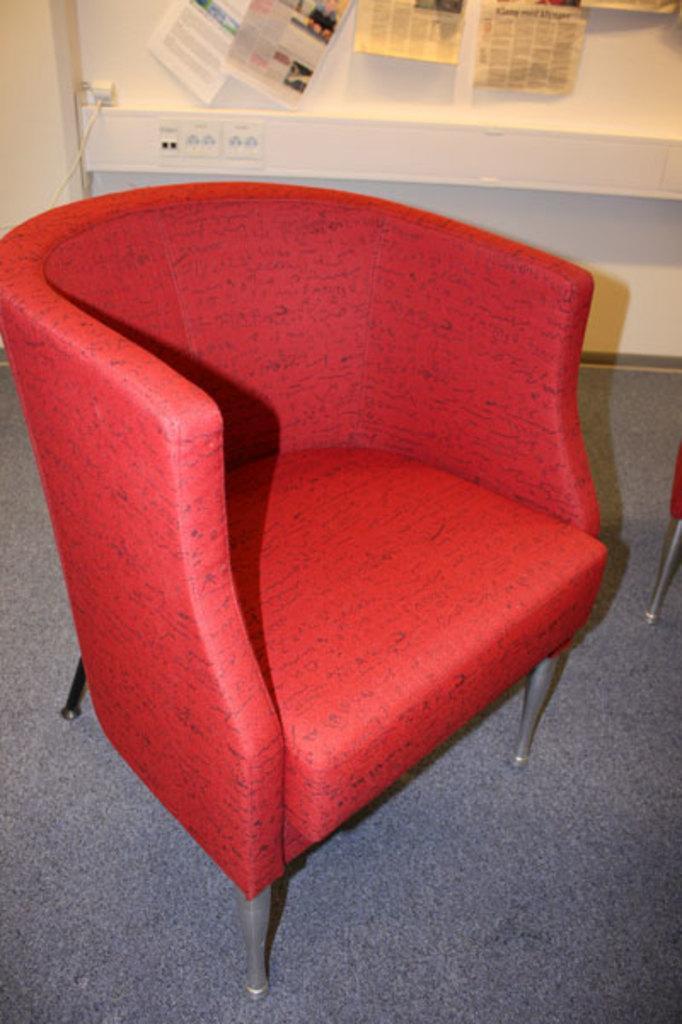Describe this image in one or two sentences. In the image we can see chairs, carpet and cable wire. Here we can see the wall and papers stick to the wall. 